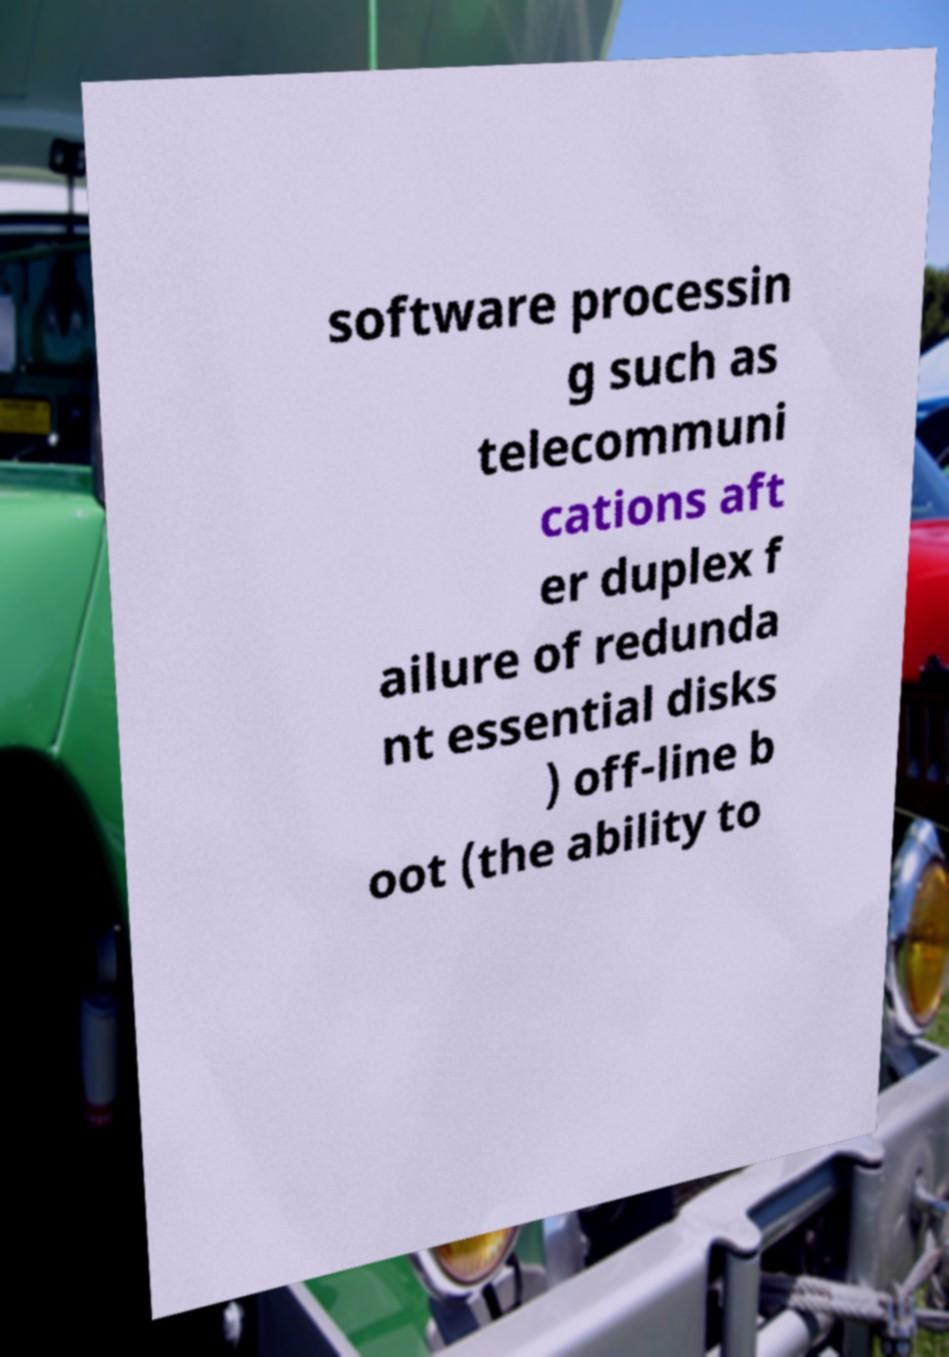Please identify and transcribe the text found in this image. software processin g such as telecommuni cations aft er duplex f ailure of redunda nt essential disks ) off-line b oot (the ability to 